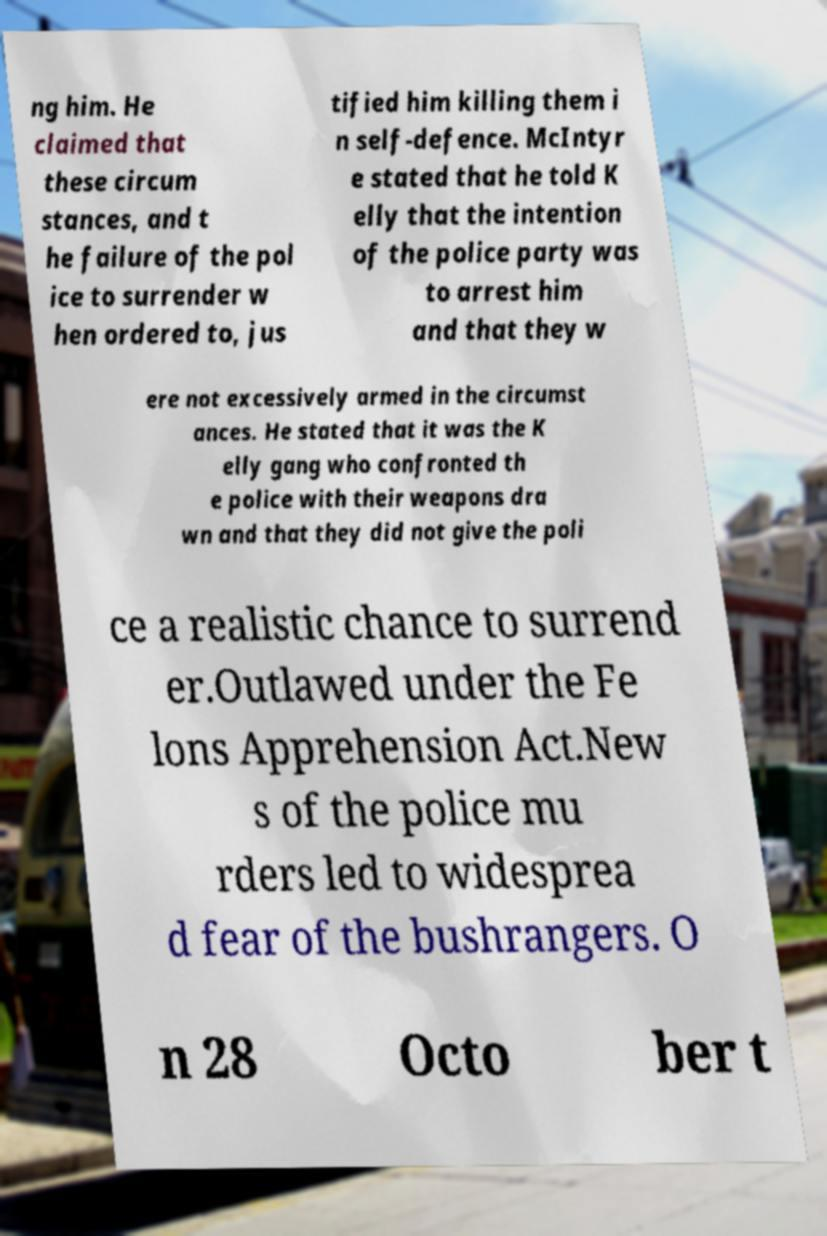Please read and relay the text visible in this image. What does it say? ng him. He claimed that these circum stances, and t he failure of the pol ice to surrender w hen ordered to, jus tified him killing them i n self-defence. McIntyr e stated that he told K elly that the intention of the police party was to arrest him and that they w ere not excessively armed in the circumst ances. He stated that it was the K elly gang who confronted th e police with their weapons dra wn and that they did not give the poli ce a realistic chance to surrend er.Outlawed under the Fe lons Apprehension Act.New s of the police mu rders led to widesprea d fear of the bushrangers. O n 28 Octo ber t 